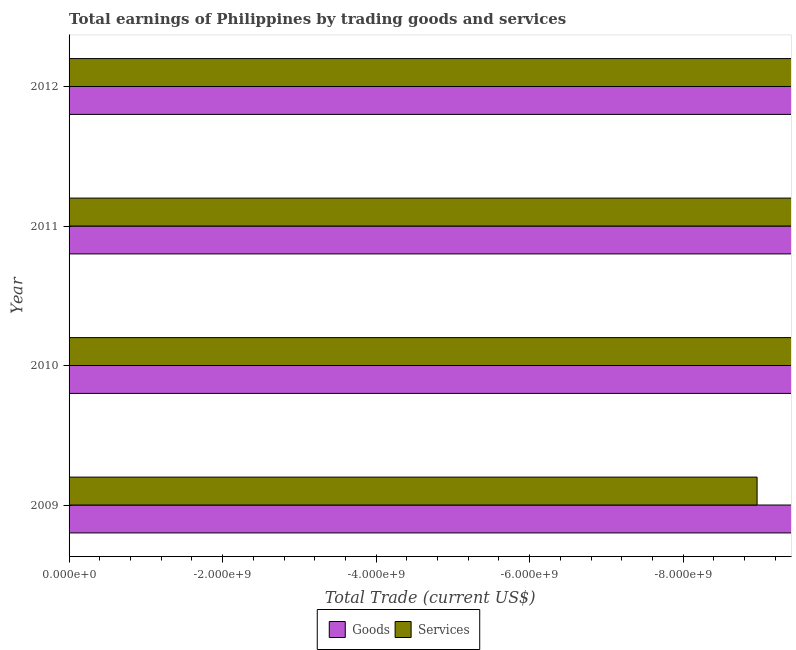How many different coloured bars are there?
Offer a very short reply. 0. Are the number of bars on each tick of the Y-axis equal?
Make the answer very short. Yes. How many bars are there on the 3rd tick from the top?
Your answer should be compact. 0. How many bars are there on the 3rd tick from the bottom?
Keep it short and to the point. 0. In how many cases, is the number of bars for a given year not equal to the number of legend labels?
Your response must be concise. 4. What is the total amount earned by trading services in the graph?
Keep it short and to the point. 0. Are all the bars in the graph horizontal?
Offer a very short reply. Yes. How many years are there in the graph?
Offer a very short reply. 4. Are the values on the major ticks of X-axis written in scientific E-notation?
Provide a succinct answer. Yes. What is the title of the graph?
Give a very brief answer. Total earnings of Philippines by trading goods and services. What is the label or title of the X-axis?
Your answer should be compact. Total Trade (current US$). What is the Total Trade (current US$) in Goods in 2010?
Your answer should be very brief. 0. What is the Total Trade (current US$) in Services in 2010?
Offer a very short reply. 0. 